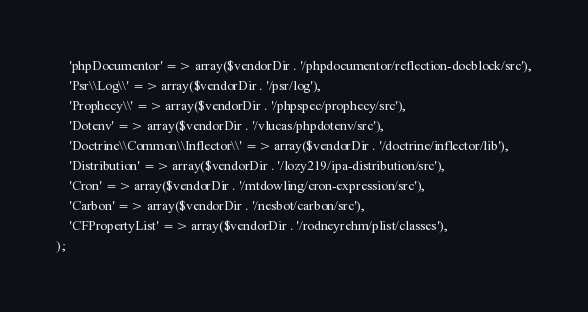Convert code to text. <code><loc_0><loc_0><loc_500><loc_500><_PHP_>    'phpDocumentor' => array($vendorDir . '/phpdocumentor/reflection-docblock/src'),
    'Psr\\Log\\' => array($vendorDir . '/psr/log'),
    'Prophecy\\' => array($vendorDir . '/phpspec/prophecy/src'),
    'Dotenv' => array($vendorDir . '/vlucas/phpdotenv/src'),
    'Doctrine\\Common\\Inflector\\' => array($vendorDir . '/doctrine/inflector/lib'),
    'Distribution' => array($vendorDir . '/lozy219/ipa-distribution/src'),
    'Cron' => array($vendorDir . '/mtdowling/cron-expression/src'),
    'Carbon' => array($vendorDir . '/nesbot/carbon/src'),
    'CFPropertyList' => array($vendorDir . '/rodneyrehm/plist/classes'),
);
</code> 